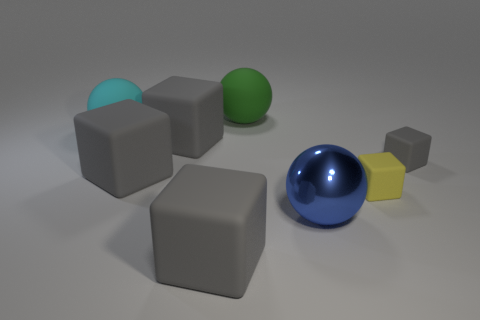Subtract all gray cubes. How many were subtracted if there are1gray cubes left? 3 Subtract all green balls. How many gray blocks are left? 4 Subtract 1 cubes. How many cubes are left? 4 Subtract all yellow cubes. How many cubes are left? 4 Subtract all yellow blocks. How many blocks are left? 4 Add 2 big balls. How many objects exist? 10 Subtract all blue cubes. Subtract all red cylinders. How many cubes are left? 5 Subtract all cubes. How many objects are left? 3 Subtract all large rubber spheres. Subtract all green objects. How many objects are left? 5 Add 6 tiny yellow rubber things. How many tiny yellow rubber things are left? 7 